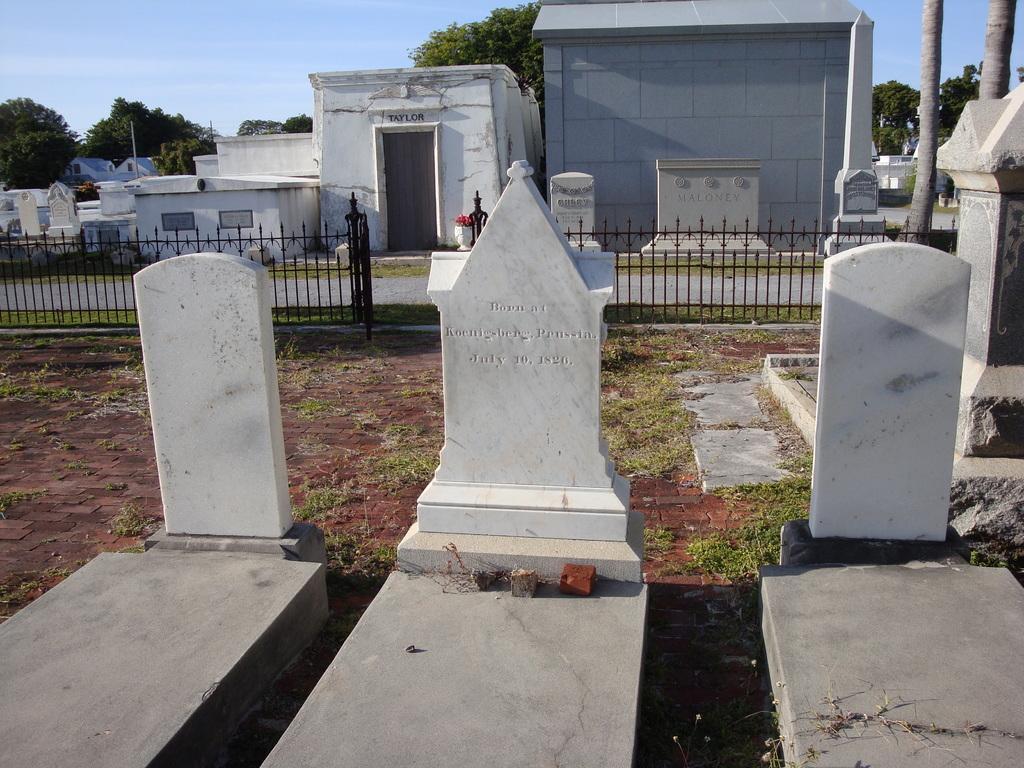How would you summarize this image in a sentence or two? This image is taken in a graveyard. In the center of the image there are graves. In the background of the image there are trees. There is a fencing. 